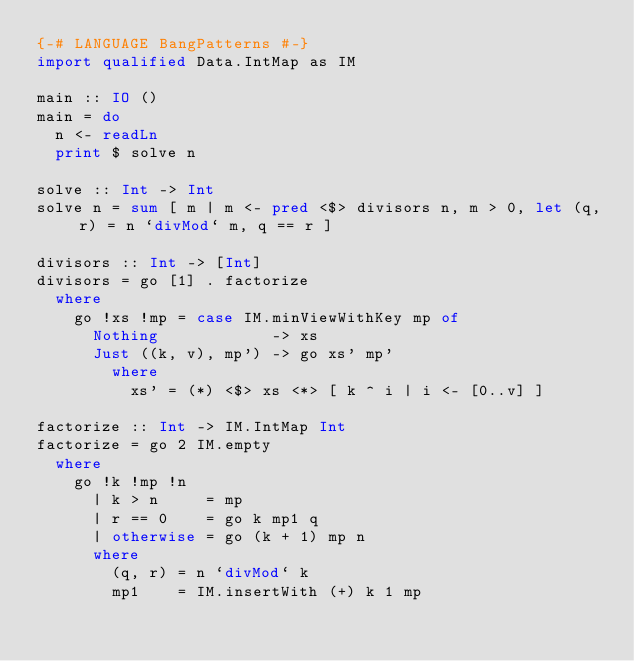<code> <loc_0><loc_0><loc_500><loc_500><_Haskell_>{-# LANGUAGE BangPatterns #-}
import qualified Data.IntMap as IM

main :: IO ()
main = do
  n <- readLn
  print $ solve n

solve :: Int -> Int
solve n = sum [ m | m <- pred <$> divisors n, m > 0, let (q, r) = n `divMod` m, q == r ]

divisors :: Int -> [Int]
divisors = go [1] . factorize
  where
    go !xs !mp = case IM.minViewWithKey mp of
      Nothing            -> xs
      Just ((k, v), mp') -> go xs' mp'
        where
          xs' = (*) <$> xs <*> [ k ^ i | i <- [0..v] ]

factorize :: Int -> IM.IntMap Int
factorize = go 2 IM.empty
  where
    go !k !mp !n
      | k > n     = mp
      | r == 0    = go k mp1 q
      | otherwise = go (k + 1) mp n
      where
        (q, r) = n `divMod` k
        mp1    = IM.insertWith (+) k 1 mp
</code> 